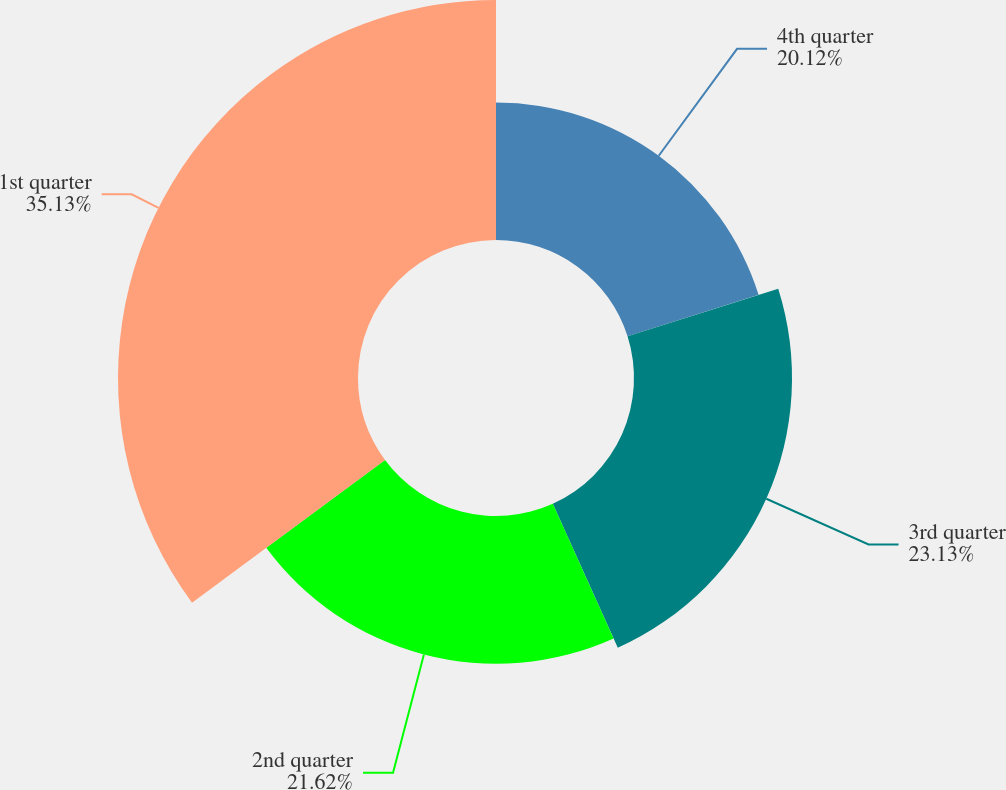Convert chart. <chart><loc_0><loc_0><loc_500><loc_500><pie_chart><fcel>4th quarter<fcel>3rd quarter<fcel>2nd quarter<fcel>1st quarter<nl><fcel>20.12%<fcel>23.13%<fcel>21.62%<fcel>35.13%<nl></chart> 